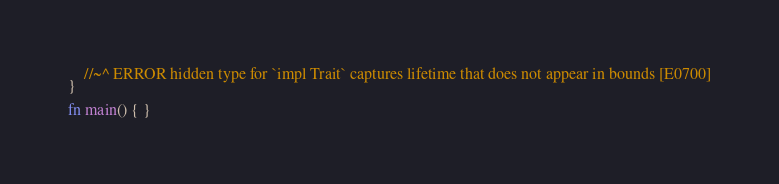Convert code to text. <code><loc_0><loc_0><loc_500><loc_500><_Rust_>    //~^ ERROR hidden type for `impl Trait` captures lifetime that does not appear in bounds [E0700]
}

fn main() { }
</code> 